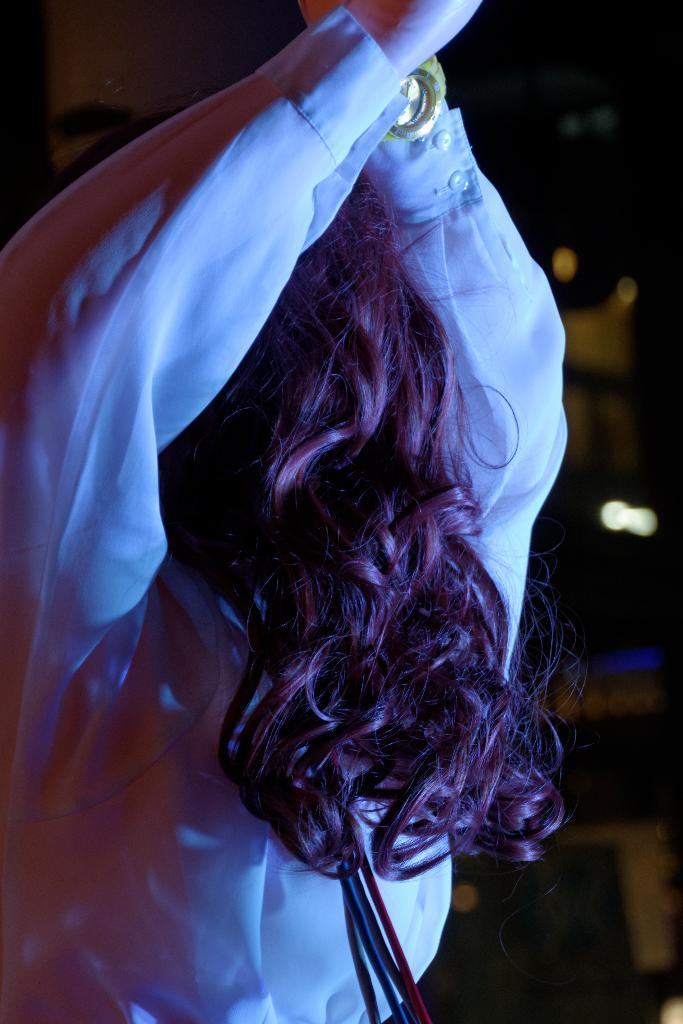Who or what is the main subject in the image? There is a person in the image. Can you describe the background of the image? The background of the image is blurry and dark. What type of horse can be seen on top of the wave in the image? There is no horse or wave present in the image; it features a person with a blurry and dark background. 